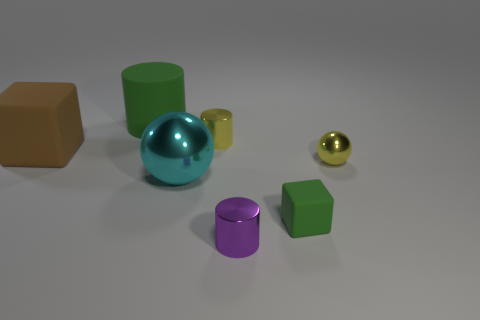What is the material of the green object that is the same size as the brown object?
Your answer should be compact. Rubber. What number of shiny objects are green objects or tiny blue things?
Your answer should be very brief. 0. What color is the thing that is behind the large brown object and to the right of the big matte cylinder?
Your answer should be compact. Yellow. How many large balls are left of the big cylinder?
Your response must be concise. 0. What material is the brown cube?
Ensure brevity in your answer.  Rubber. What is the color of the shiny cylinder on the left side of the small purple object that is on the right side of the small object that is behind the small shiny ball?
Provide a short and direct response. Yellow. What number of cyan metallic things are the same size as the brown rubber object?
Make the answer very short. 1. There is a big matte object that is on the left side of the large green cylinder; what color is it?
Make the answer very short. Brown. What number of other things are there of the same size as the purple metallic thing?
Ensure brevity in your answer.  3. There is a rubber thing that is both behind the large metallic object and right of the brown object; what is its size?
Make the answer very short. Large. 